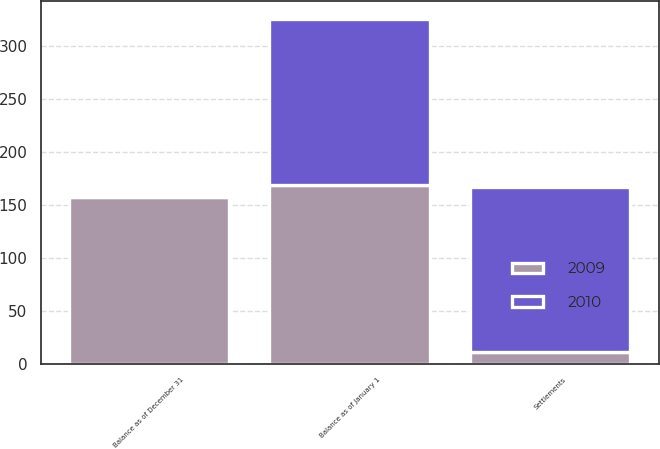Convert chart. <chart><loc_0><loc_0><loc_500><loc_500><stacked_bar_chart><ecel><fcel>Balance as of January 1<fcel>Settlements<fcel>Balance as of December 31<nl><fcel>2010<fcel>157<fcel>156.3<fcel>1.3<nl><fcel>2009<fcel>168.9<fcel>10.5<fcel>157<nl></chart> 